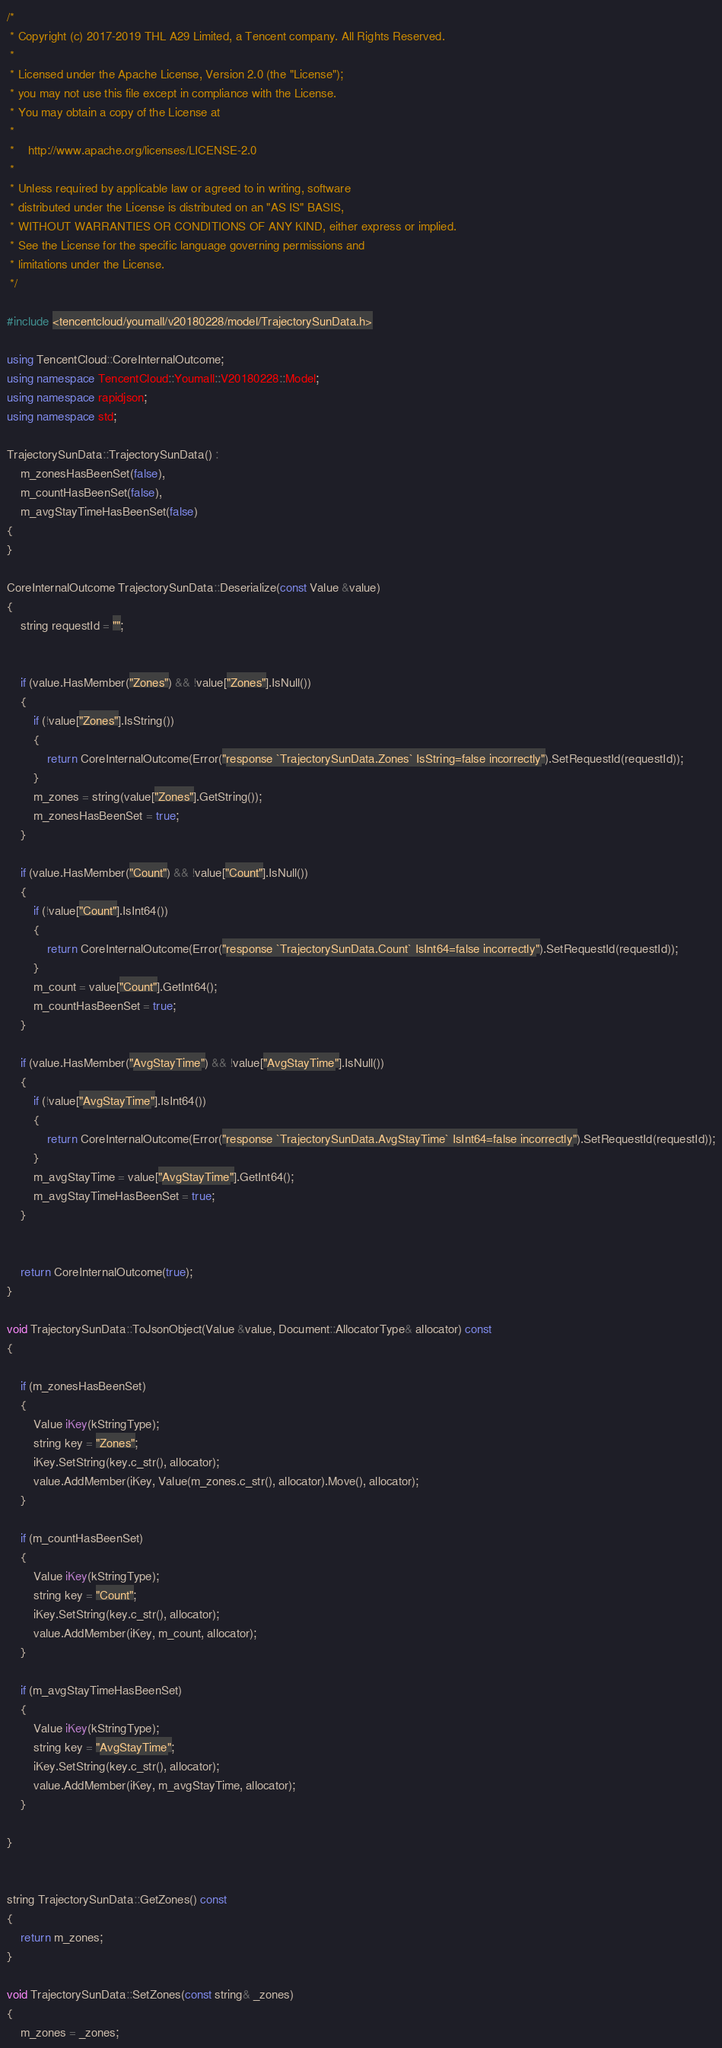Convert code to text. <code><loc_0><loc_0><loc_500><loc_500><_C++_>/*
 * Copyright (c) 2017-2019 THL A29 Limited, a Tencent company. All Rights Reserved.
 *
 * Licensed under the Apache License, Version 2.0 (the "License");
 * you may not use this file except in compliance with the License.
 * You may obtain a copy of the License at
 *
 *    http://www.apache.org/licenses/LICENSE-2.0
 *
 * Unless required by applicable law or agreed to in writing, software
 * distributed under the License is distributed on an "AS IS" BASIS,
 * WITHOUT WARRANTIES OR CONDITIONS OF ANY KIND, either express or implied.
 * See the License for the specific language governing permissions and
 * limitations under the License.
 */

#include <tencentcloud/youmall/v20180228/model/TrajectorySunData.h>

using TencentCloud::CoreInternalOutcome;
using namespace TencentCloud::Youmall::V20180228::Model;
using namespace rapidjson;
using namespace std;

TrajectorySunData::TrajectorySunData() :
    m_zonesHasBeenSet(false),
    m_countHasBeenSet(false),
    m_avgStayTimeHasBeenSet(false)
{
}

CoreInternalOutcome TrajectorySunData::Deserialize(const Value &value)
{
    string requestId = "";


    if (value.HasMember("Zones") && !value["Zones"].IsNull())
    {
        if (!value["Zones"].IsString())
        {
            return CoreInternalOutcome(Error("response `TrajectorySunData.Zones` IsString=false incorrectly").SetRequestId(requestId));
        }
        m_zones = string(value["Zones"].GetString());
        m_zonesHasBeenSet = true;
    }

    if (value.HasMember("Count") && !value["Count"].IsNull())
    {
        if (!value["Count"].IsInt64())
        {
            return CoreInternalOutcome(Error("response `TrajectorySunData.Count` IsInt64=false incorrectly").SetRequestId(requestId));
        }
        m_count = value["Count"].GetInt64();
        m_countHasBeenSet = true;
    }

    if (value.HasMember("AvgStayTime") && !value["AvgStayTime"].IsNull())
    {
        if (!value["AvgStayTime"].IsInt64())
        {
            return CoreInternalOutcome(Error("response `TrajectorySunData.AvgStayTime` IsInt64=false incorrectly").SetRequestId(requestId));
        }
        m_avgStayTime = value["AvgStayTime"].GetInt64();
        m_avgStayTimeHasBeenSet = true;
    }


    return CoreInternalOutcome(true);
}

void TrajectorySunData::ToJsonObject(Value &value, Document::AllocatorType& allocator) const
{

    if (m_zonesHasBeenSet)
    {
        Value iKey(kStringType);
        string key = "Zones";
        iKey.SetString(key.c_str(), allocator);
        value.AddMember(iKey, Value(m_zones.c_str(), allocator).Move(), allocator);
    }

    if (m_countHasBeenSet)
    {
        Value iKey(kStringType);
        string key = "Count";
        iKey.SetString(key.c_str(), allocator);
        value.AddMember(iKey, m_count, allocator);
    }

    if (m_avgStayTimeHasBeenSet)
    {
        Value iKey(kStringType);
        string key = "AvgStayTime";
        iKey.SetString(key.c_str(), allocator);
        value.AddMember(iKey, m_avgStayTime, allocator);
    }

}


string TrajectorySunData::GetZones() const
{
    return m_zones;
}

void TrajectorySunData::SetZones(const string& _zones)
{
    m_zones = _zones;</code> 